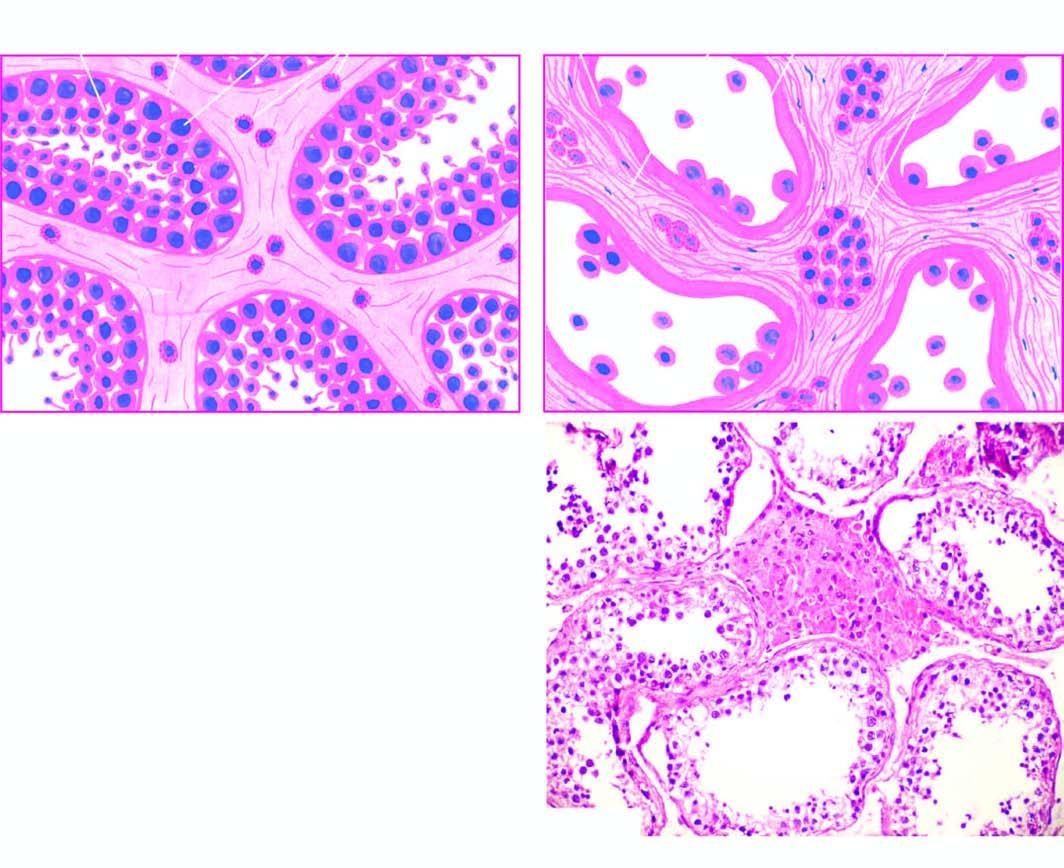how is microscopic appearance of normal testis contrasted?
Answer the question using a single word or phrase. With that of cryptorchid testis 